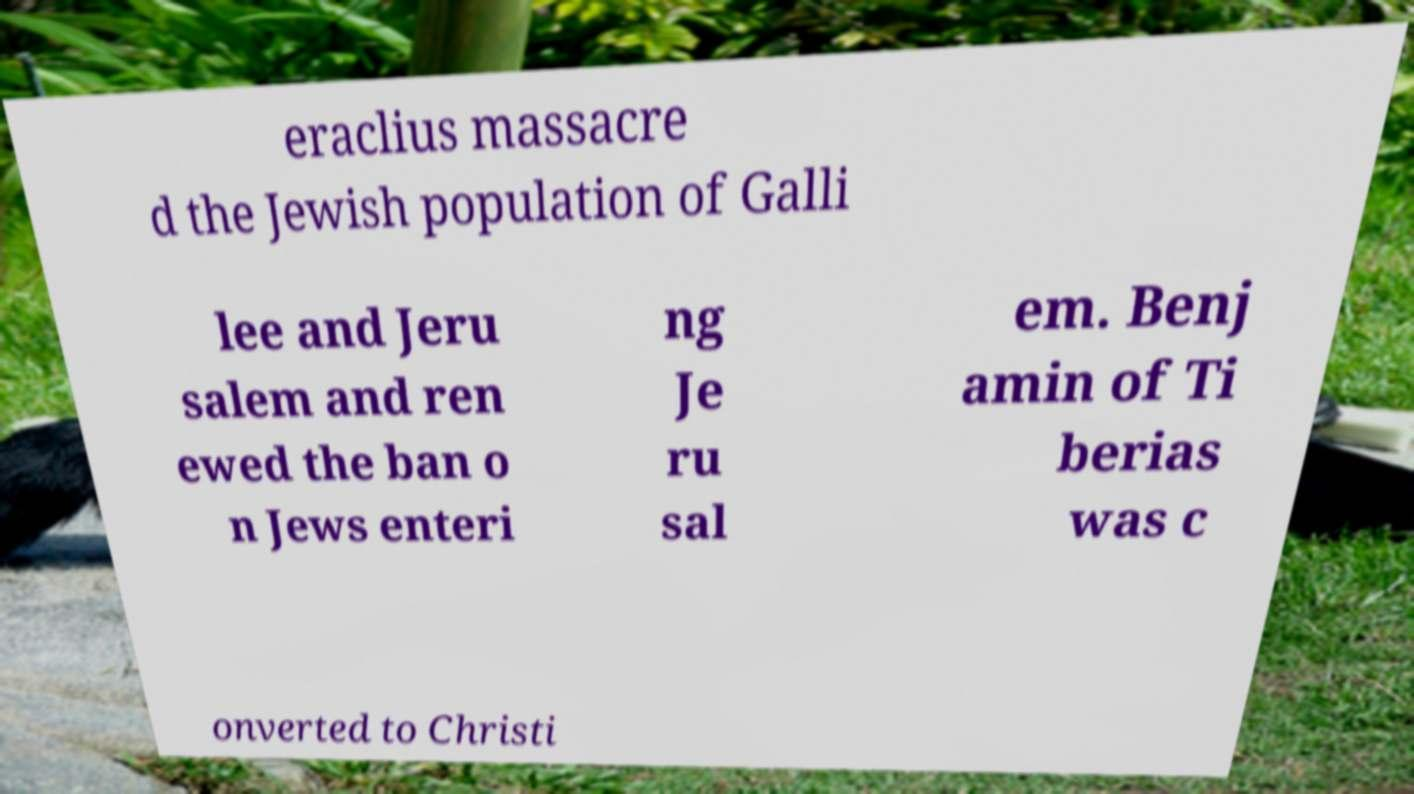Could you extract and type out the text from this image? eraclius massacre d the Jewish population of Galli lee and Jeru salem and ren ewed the ban o n Jews enteri ng Je ru sal em. Benj amin of Ti berias was c onverted to Christi 